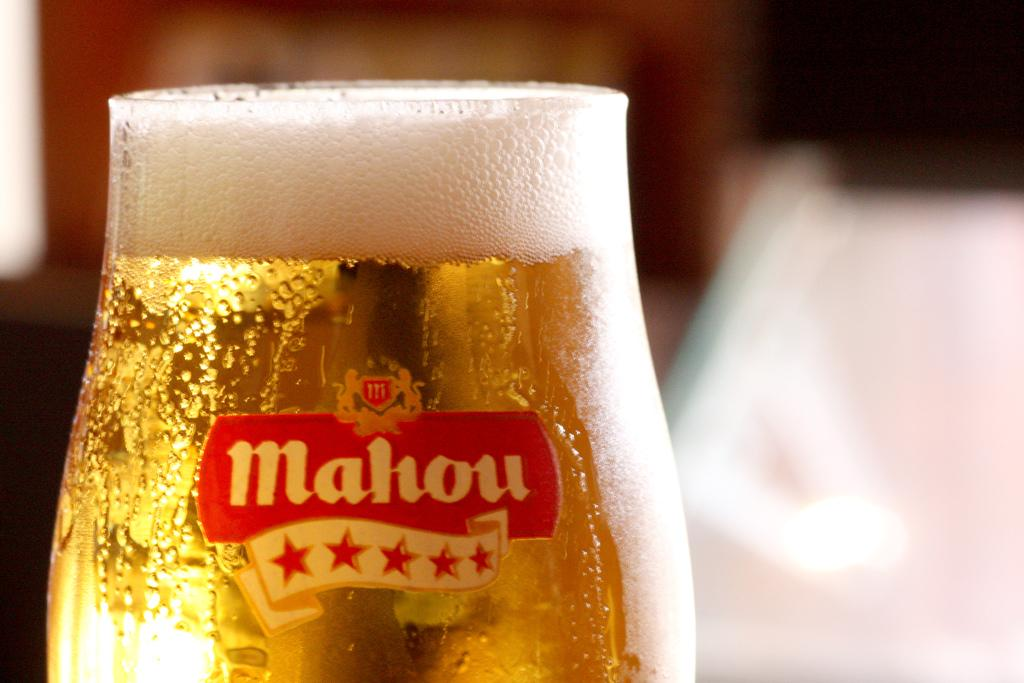<image>
Render a clear and concise summary of the photo. A glass of beer that says Mahou on it. 